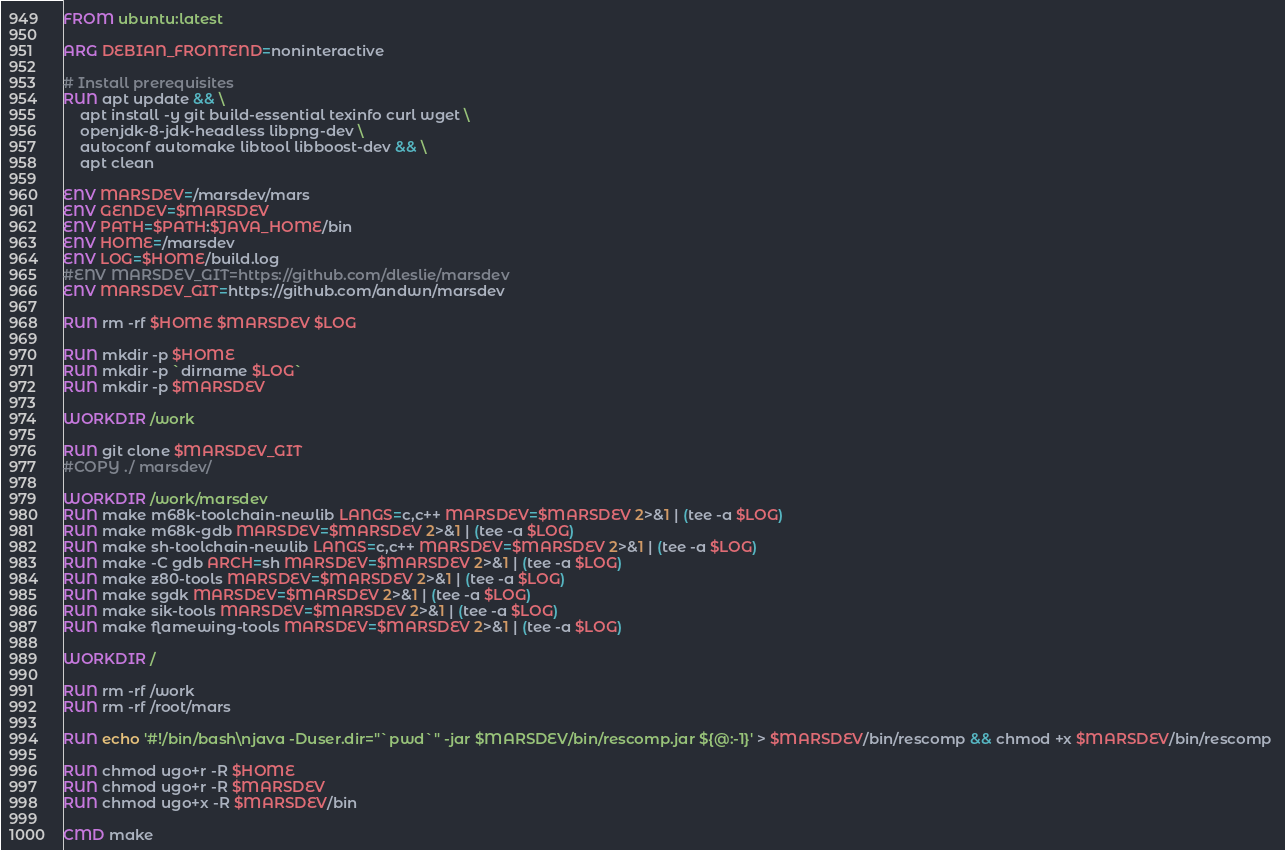Convert code to text. <code><loc_0><loc_0><loc_500><loc_500><_Dockerfile_>FROM ubuntu:latest

ARG DEBIAN_FRONTEND=noninteractive

# Install prerequisites
RUN apt update && \
    apt install -y git build-essential texinfo curl wget \
    openjdk-8-jdk-headless libpng-dev \
    autoconf automake libtool libboost-dev && \
    apt clean

ENV MARSDEV=/marsdev/mars
ENV GENDEV=$MARSDEV
ENV PATH=$PATH:$JAVA_HOME/bin
ENV HOME=/marsdev
ENV LOG=$HOME/build.log
#ENV MARSDEV_GIT=https://github.com/dleslie/marsdev
ENV MARSDEV_GIT=https://github.com/andwn/marsdev

RUN rm -rf $HOME $MARSDEV $LOG

RUN mkdir -p $HOME
RUN mkdir -p `dirname $LOG`
RUN mkdir -p $MARSDEV

WORKDIR /work

RUN git clone $MARSDEV_GIT
#COPY ./ marsdev/

WORKDIR /work/marsdev
RUN make m68k-toolchain-newlib LANGS=c,c++ MARSDEV=$MARSDEV 2>&1 | (tee -a $LOG)
RUN make m68k-gdb MARSDEV=$MARSDEV 2>&1 | (tee -a $LOG)
RUN make sh-toolchain-newlib LANGS=c,c++ MARSDEV=$MARSDEV 2>&1 | (tee -a $LOG)
RUN make -C gdb ARCH=sh MARSDEV=$MARSDEV 2>&1 | (tee -a $LOG)
RUN make z80-tools MARSDEV=$MARSDEV 2>&1 | (tee -a $LOG)
RUN make sgdk MARSDEV=$MARSDEV 2>&1 | (tee -a $LOG)
RUN make sik-tools MARSDEV=$MARSDEV 2>&1 | (tee -a $LOG)
RUN make flamewing-tools MARSDEV=$MARSDEV 2>&1 | (tee -a $LOG)

WORKDIR /

RUN rm -rf /work
RUN rm -rf /root/mars

RUN echo '#!/bin/bash\njava -Duser.dir="`pwd`" -jar $MARSDEV/bin/rescomp.jar ${@:-1}' > $MARSDEV/bin/rescomp && chmod +x $MARSDEV/bin/rescomp 

RUN chmod ugo+r -R $HOME
RUN chmod ugo+r -R $MARSDEV
RUN chmod ugo+x -R $MARSDEV/bin

CMD make
</code> 